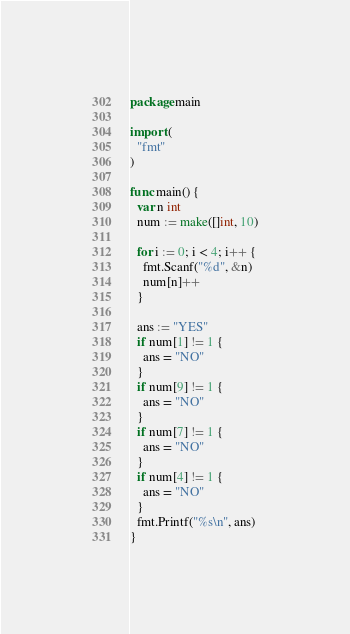Convert code to text. <code><loc_0><loc_0><loc_500><loc_500><_Go_>package main

import (
  "fmt"
)

func main() {
  var n int
  num := make([]int, 10)
  
  for i := 0; i < 4; i++ {
    fmt.Scanf("%d", &n)
    num[n]++
  }
  
  ans := "YES"
  if num[1] != 1 {
    ans = "NO"
  }
  if num[9] != 1 {
    ans = "NO"
  }
  if num[7] != 1 {
    ans = "NO"
  }
  if num[4] != 1 {
    ans = "NO"
  }
  fmt.Printf("%s\n", ans)
}</code> 